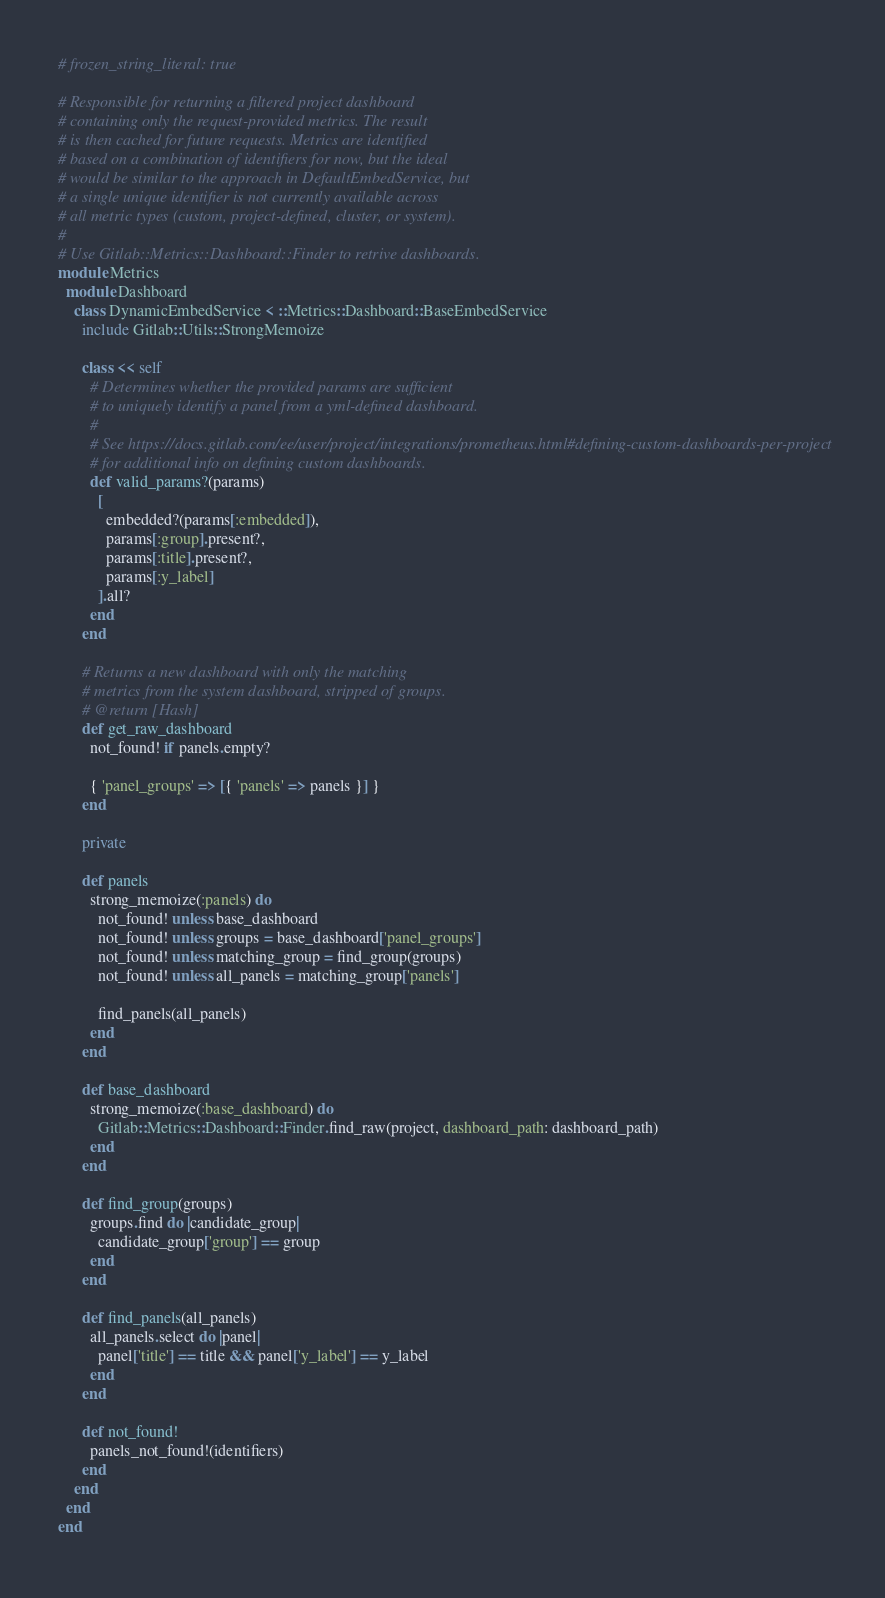<code> <loc_0><loc_0><loc_500><loc_500><_Ruby_># frozen_string_literal: true

# Responsible for returning a filtered project dashboard
# containing only the request-provided metrics. The result
# is then cached for future requests. Metrics are identified
# based on a combination of identifiers for now, but the ideal
# would be similar to the approach in DefaultEmbedService, but
# a single unique identifier is not currently available across
# all metric types (custom, project-defined, cluster, or system).
#
# Use Gitlab::Metrics::Dashboard::Finder to retrive dashboards.
module Metrics
  module Dashboard
    class DynamicEmbedService < ::Metrics::Dashboard::BaseEmbedService
      include Gitlab::Utils::StrongMemoize

      class << self
        # Determines whether the provided params are sufficient
        # to uniquely identify a panel from a yml-defined dashboard.
        #
        # See https://docs.gitlab.com/ee/user/project/integrations/prometheus.html#defining-custom-dashboards-per-project
        # for additional info on defining custom dashboards.
        def valid_params?(params)
          [
            embedded?(params[:embedded]),
            params[:group].present?,
            params[:title].present?,
            params[:y_label]
          ].all?
        end
      end

      # Returns a new dashboard with only the matching
      # metrics from the system dashboard, stripped of groups.
      # @return [Hash]
      def get_raw_dashboard
        not_found! if panels.empty?

        { 'panel_groups' => [{ 'panels' => panels }] }
      end

      private

      def panels
        strong_memoize(:panels) do
          not_found! unless base_dashboard
          not_found! unless groups = base_dashboard['panel_groups']
          not_found! unless matching_group = find_group(groups)
          not_found! unless all_panels = matching_group['panels']

          find_panels(all_panels)
        end
      end

      def base_dashboard
        strong_memoize(:base_dashboard) do
          Gitlab::Metrics::Dashboard::Finder.find_raw(project, dashboard_path: dashboard_path)
        end
      end

      def find_group(groups)
        groups.find do |candidate_group|
          candidate_group['group'] == group
        end
      end

      def find_panels(all_panels)
        all_panels.select do |panel|
          panel['title'] == title && panel['y_label'] == y_label
        end
      end

      def not_found!
        panels_not_found!(identifiers)
      end
    end
  end
end
</code> 